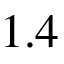Convert formula to latex. <formula><loc_0><loc_0><loc_500><loc_500>1 . 4</formula> 